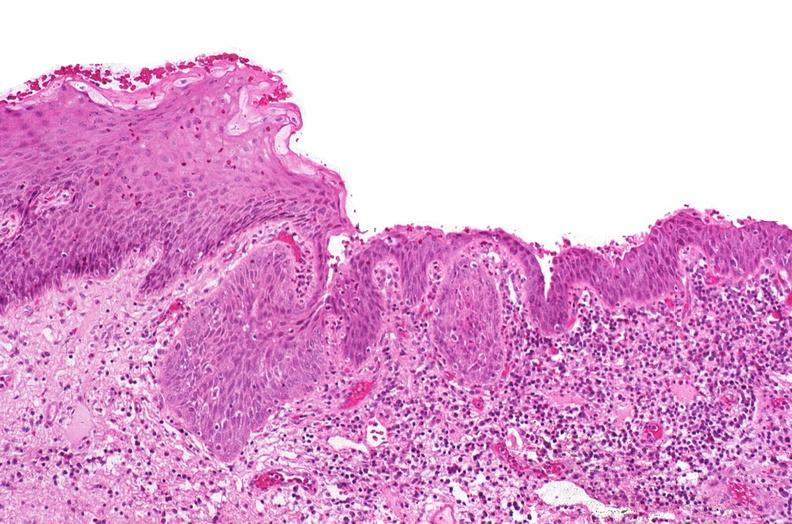why does this image show renal pelvis, squamous metaplasia?
Answer the question using a single word or phrase. Due to chronic urolithiasis 